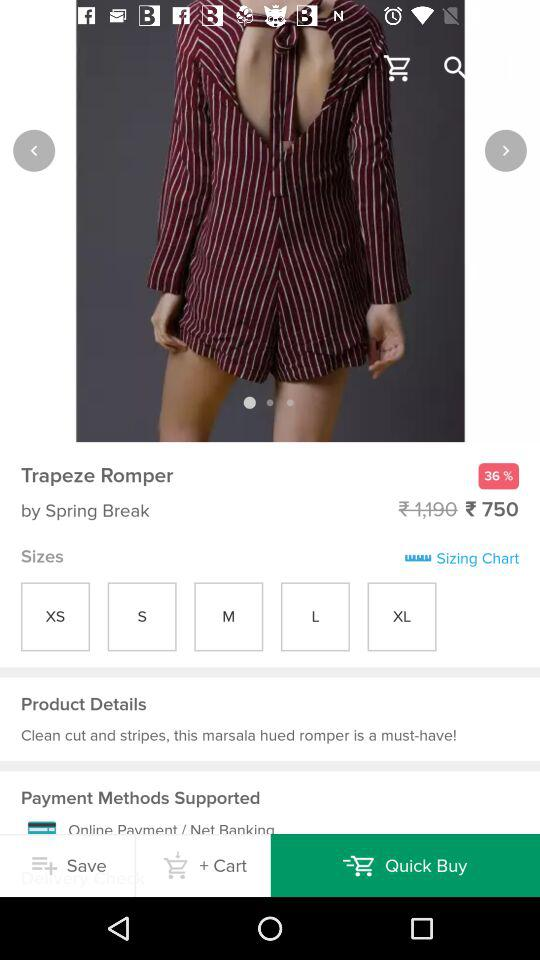Which tab is selected?
When the provided information is insufficient, respond with <no answer>. <no answer> 